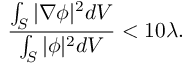Convert formula to latex. <formula><loc_0><loc_0><loc_500><loc_500>\frac { \int _ { S } | \nabla \phi | ^ { 2 } d V } { \int _ { S } | \phi | ^ { 2 } d V } < 1 0 \lambda .</formula> 